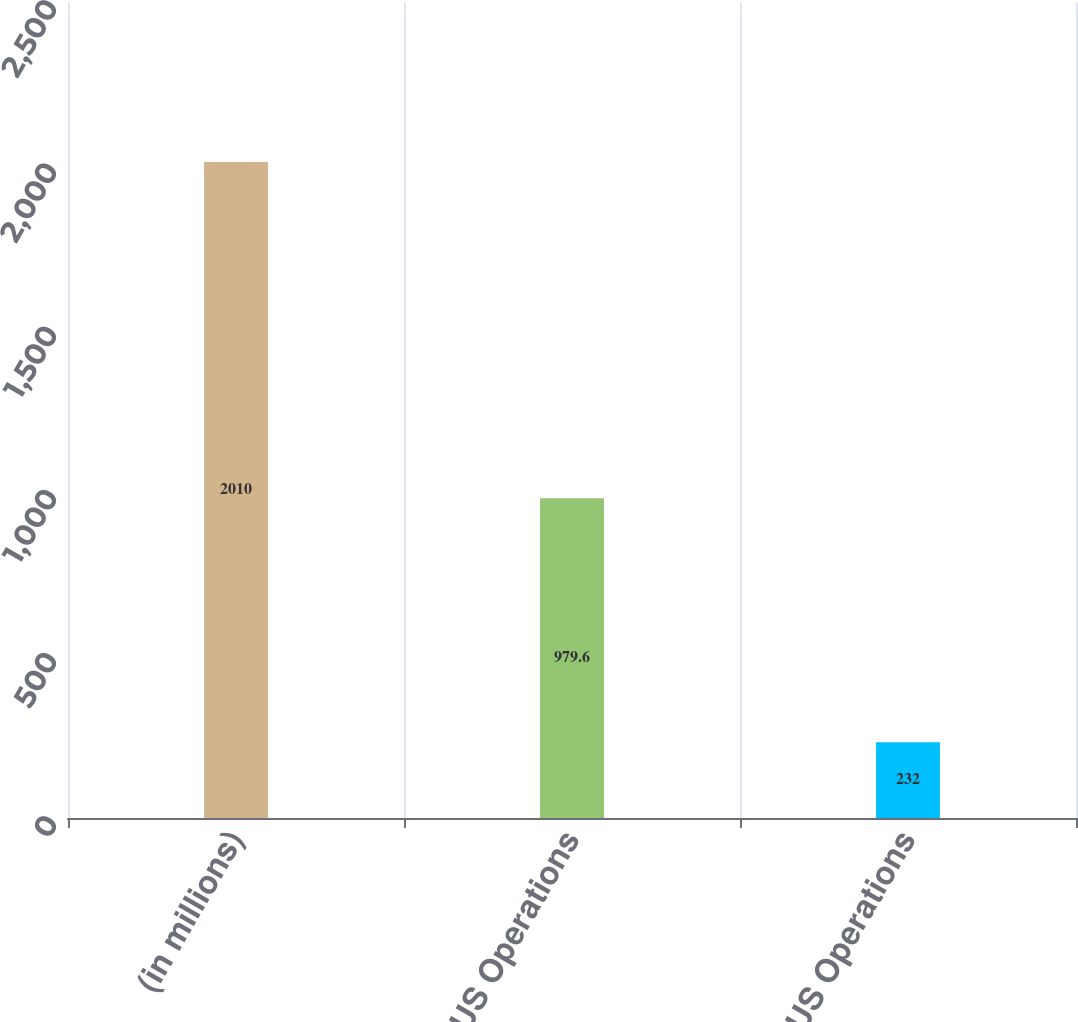Convert chart. <chart><loc_0><loc_0><loc_500><loc_500><bar_chart><fcel>(in millions)<fcel>US Operations<fcel>Non-US Operations<nl><fcel>2010<fcel>979.6<fcel>232<nl></chart> 